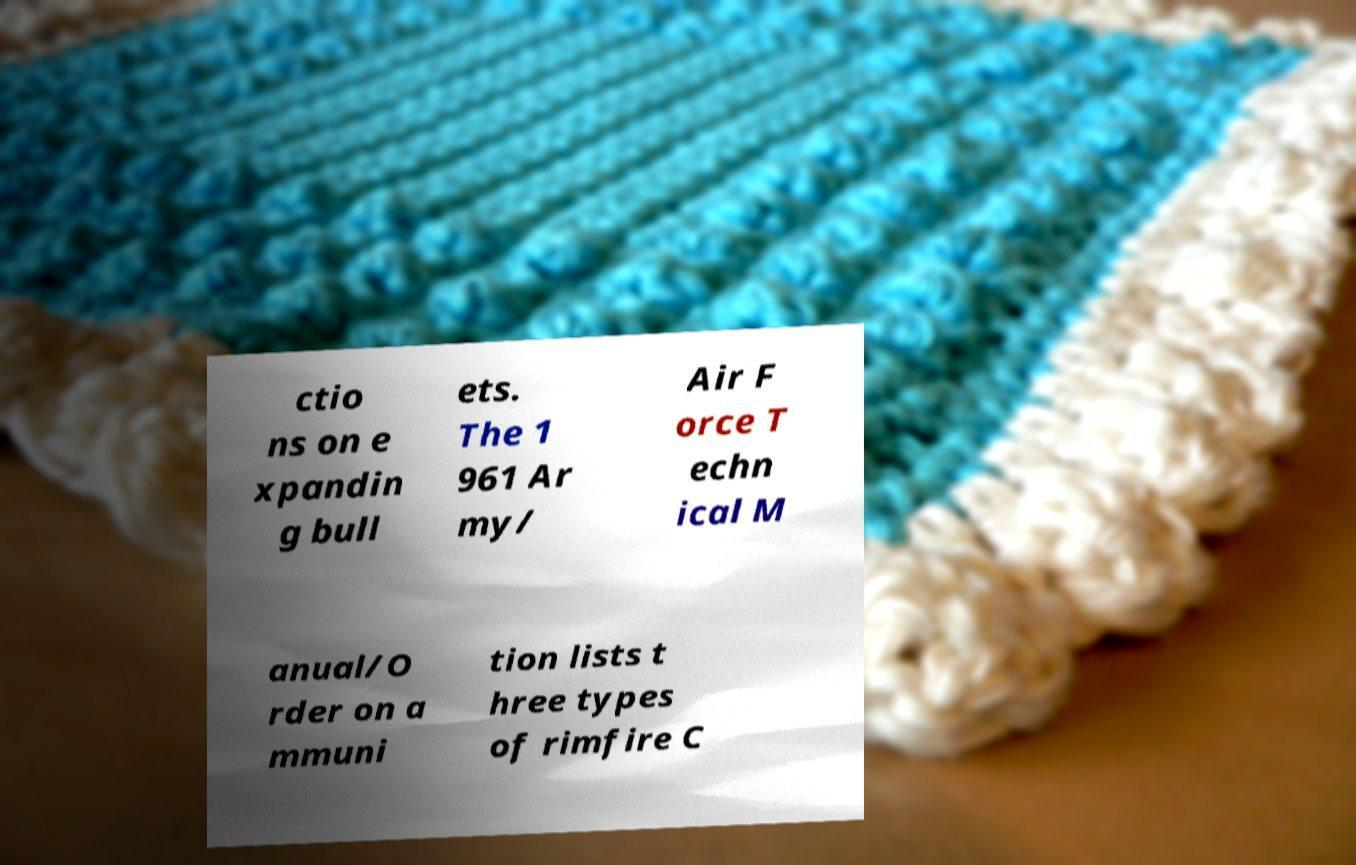Please read and relay the text visible in this image. What does it say? ctio ns on e xpandin g bull ets. The 1 961 Ar my/ Air F orce T echn ical M anual/O rder on a mmuni tion lists t hree types of rimfire C 